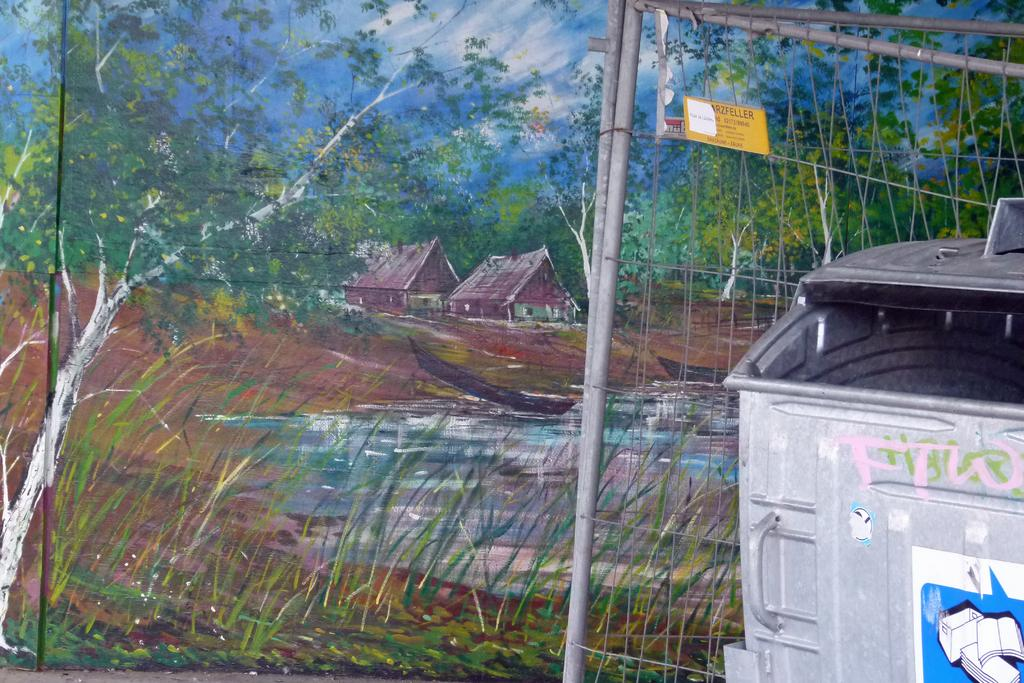What object is present in the image for waste disposal? There is a dustbin in the image. What type of barrier can be seen in the image? There is fencing in the image. What type of artwork is visible in the background of the image? There is a painting on the wall in the background of the image. What type of steel is used to construct the coach in the image? There is no coach present in the image, so it is not possible to determine the type of steel used in its construction. 